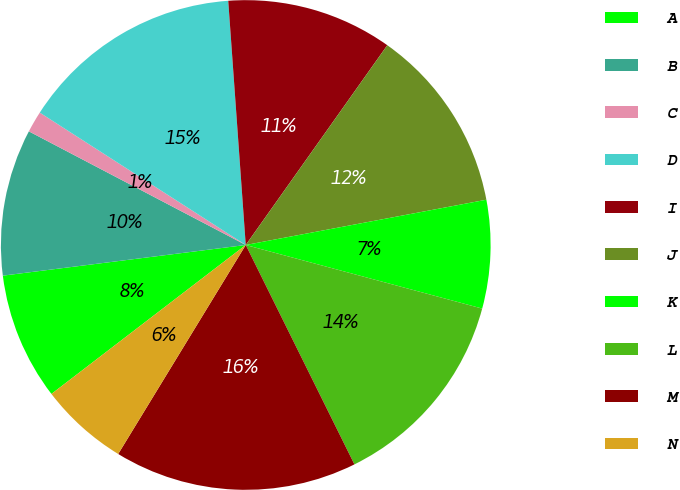<chart> <loc_0><loc_0><loc_500><loc_500><pie_chart><fcel>A<fcel>B<fcel>C<fcel>D<fcel>I<fcel>J<fcel>K<fcel>L<fcel>M<fcel>N<nl><fcel>8.41%<fcel>9.68%<fcel>1.41%<fcel>14.77%<fcel>10.95%<fcel>12.23%<fcel>7.14%<fcel>13.5%<fcel>16.04%<fcel>5.87%<nl></chart> 